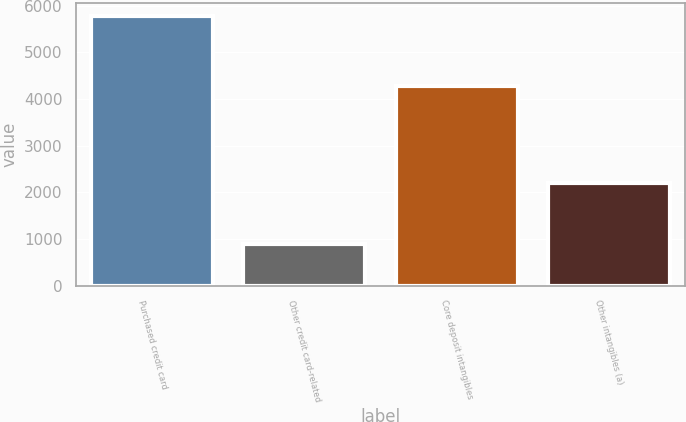Convert chart. <chart><loc_0><loc_0><loc_500><loc_500><bar_chart><fcel>Purchased credit card<fcel>Other credit card-related<fcel>Core deposit intangibles<fcel>Other intangibles (a)<nl><fcel>5783<fcel>894<fcel>4280<fcel>2200<nl></chart> 